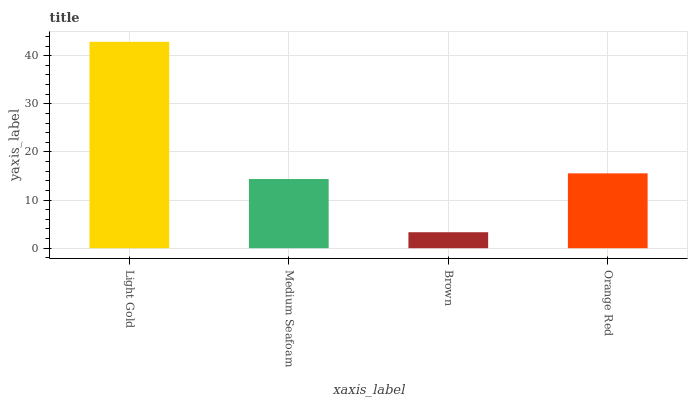Is Medium Seafoam the minimum?
Answer yes or no. No. Is Medium Seafoam the maximum?
Answer yes or no. No. Is Light Gold greater than Medium Seafoam?
Answer yes or no. Yes. Is Medium Seafoam less than Light Gold?
Answer yes or no. Yes. Is Medium Seafoam greater than Light Gold?
Answer yes or no. No. Is Light Gold less than Medium Seafoam?
Answer yes or no. No. Is Orange Red the high median?
Answer yes or no. Yes. Is Medium Seafoam the low median?
Answer yes or no. Yes. Is Medium Seafoam the high median?
Answer yes or no. No. Is Light Gold the low median?
Answer yes or no. No. 